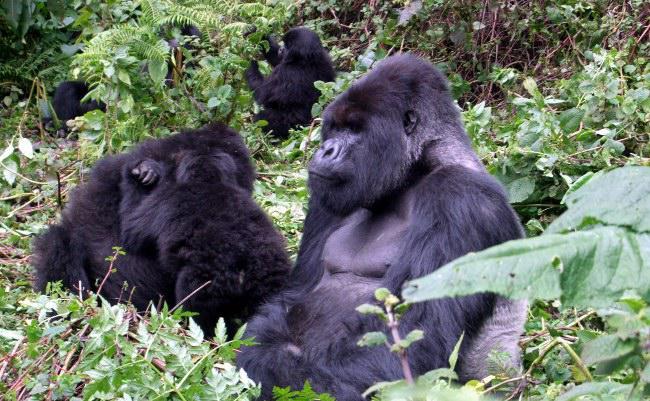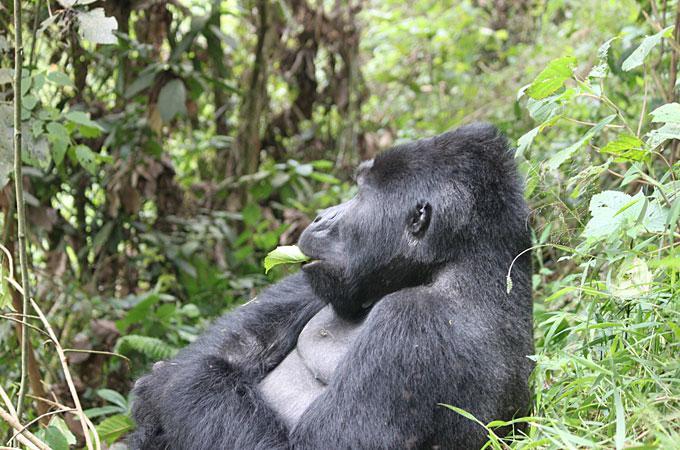The first image is the image on the left, the second image is the image on the right. For the images shown, is this caption "There are more than three apes visible, whether in foreground or background." true? Answer yes or no. Yes. 